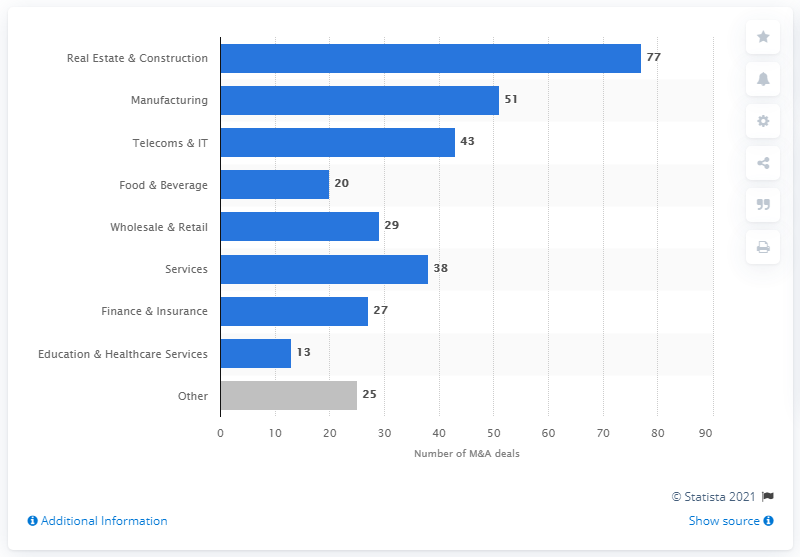Which sector had the least number of transactions, and could you speculate on the reasons why? The Education & Healthcare Services sector had the least number of transactions in 2018, with only 13 deals. This could be due to the specialized nature of these industries, regulatory challenges, or perhaps these sectors are less fragmented than others, leading to fewer consolidation opportunities in the Polish market. 